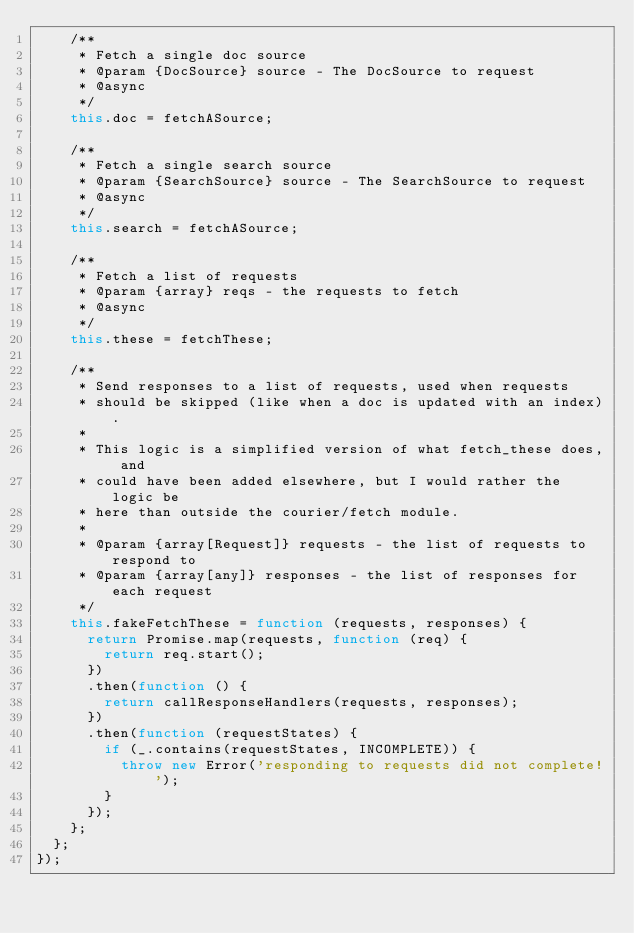Convert code to text. <code><loc_0><loc_0><loc_500><loc_500><_JavaScript_>    /**
     * Fetch a single doc source
     * @param {DocSource} source - The DocSource to request
     * @async
     */
    this.doc = fetchASource;

    /**
     * Fetch a single search source
     * @param {SearchSource} source - The SearchSource to request
     * @async
     */
    this.search = fetchASource;

    /**
     * Fetch a list of requests
     * @param {array} reqs - the requests to fetch
     * @async
     */
    this.these = fetchThese;

    /**
     * Send responses to a list of requests, used when requests
     * should be skipped (like when a doc is updated with an index).
     *
     * This logic is a simplified version of what fetch_these does, and
     * could have been added elsewhere, but I would rather the logic be
     * here than outside the courier/fetch module.
     *
     * @param {array[Request]} requests - the list of requests to respond to
     * @param {array[any]} responses - the list of responses for each request
     */
    this.fakeFetchThese = function (requests, responses) {
      return Promise.map(requests, function (req) {
        return req.start();
      })
      .then(function () {
        return callResponseHandlers(requests, responses);
      })
      .then(function (requestStates) {
        if (_.contains(requestStates, INCOMPLETE)) {
          throw new Error('responding to requests did not complete!');
        }
      });
    };
  };
});
</code> 